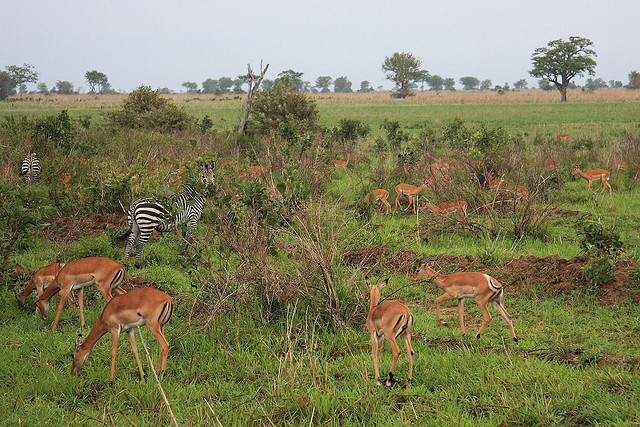Describe the objects in this image and their specific colors. I can see zebra in lightgray, black, gray, darkgreen, and darkgray tones and zebra in lightgray, black, gray, darkgreen, and darkgray tones in this image. 